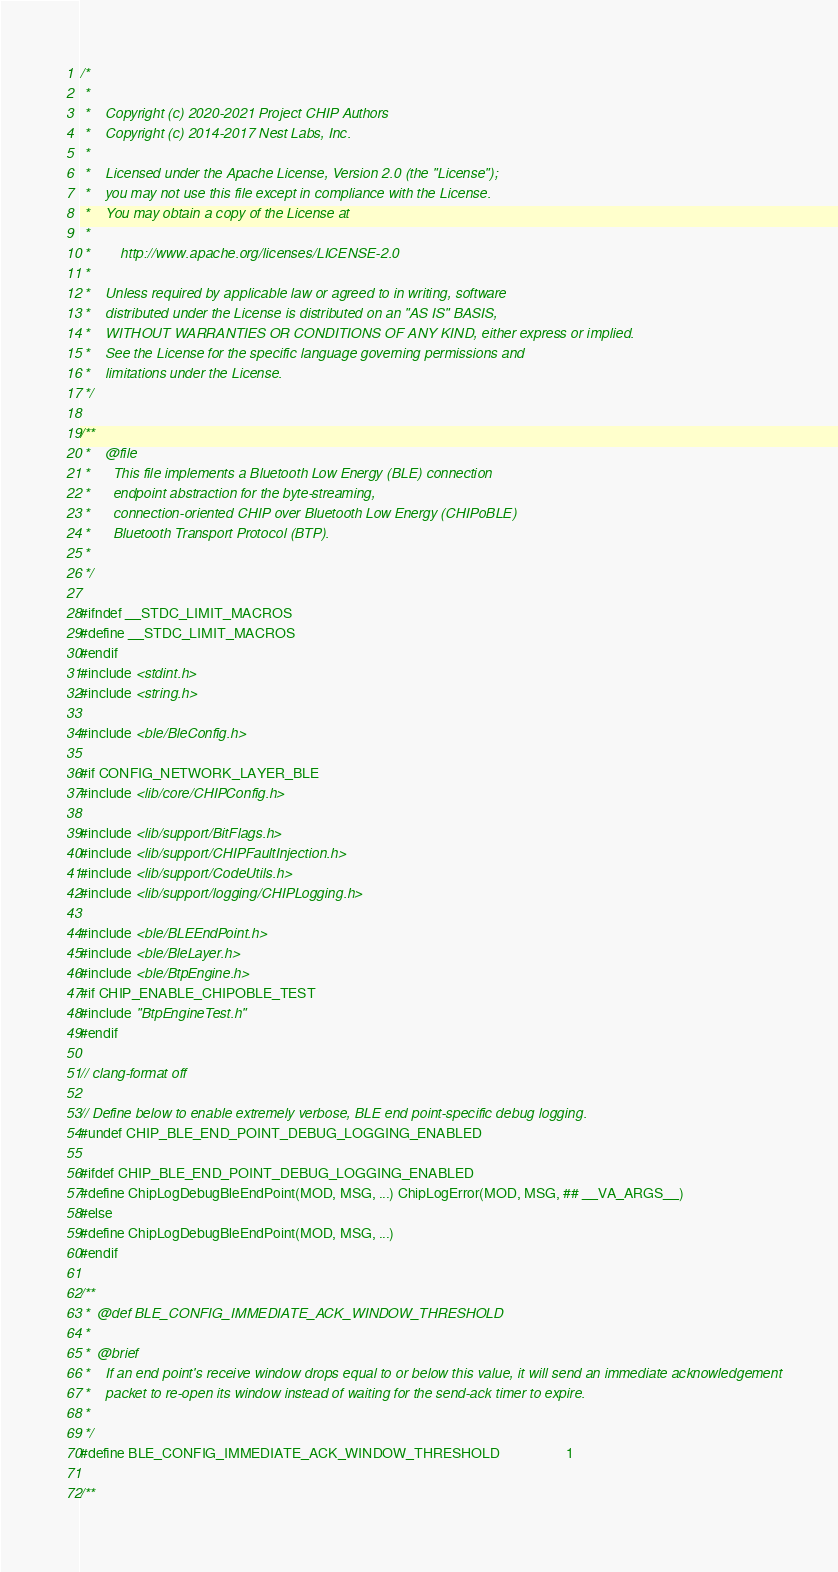<code> <loc_0><loc_0><loc_500><loc_500><_C++_>/*
 *
 *    Copyright (c) 2020-2021 Project CHIP Authors
 *    Copyright (c) 2014-2017 Nest Labs, Inc.
 *
 *    Licensed under the Apache License, Version 2.0 (the "License");
 *    you may not use this file except in compliance with the License.
 *    You may obtain a copy of the License at
 *
 *        http://www.apache.org/licenses/LICENSE-2.0
 *
 *    Unless required by applicable law or agreed to in writing, software
 *    distributed under the License is distributed on an "AS IS" BASIS,
 *    WITHOUT WARRANTIES OR CONDITIONS OF ANY KIND, either express or implied.
 *    See the License for the specific language governing permissions and
 *    limitations under the License.
 */

/**
 *    @file
 *      This file implements a Bluetooth Low Energy (BLE) connection
 *      endpoint abstraction for the byte-streaming,
 *      connection-oriented CHIP over Bluetooth Low Energy (CHIPoBLE)
 *      Bluetooth Transport Protocol (BTP).
 *
 */

#ifndef __STDC_LIMIT_MACROS
#define __STDC_LIMIT_MACROS
#endif
#include <stdint.h>
#include <string.h>

#include <ble/BleConfig.h>

#if CONFIG_NETWORK_LAYER_BLE
#include <lib/core/CHIPConfig.h>

#include <lib/support/BitFlags.h>
#include <lib/support/CHIPFaultInjection.h>
#include <lib/support/CodeUtils.h>
#include <lib/support/logging/CHIPLogging.h>

#include <ble/BLEEndPoint.h>
#include <ble/BleLayer.h>
#include <ble/BtpEngine.h>
#if CHIP_ENABLE_CHIPOBLE_TEST
#include "BtpEngineTest.h"
#endif

// clang-format off

// Define below to enable extremely verbose, BLE end point-specific debug logging.
#undef CHIP_BLE_END_POINT_DEBUG_LOGGING_ENABLED

#ifdef CHIP_BLE_END_POINT_DEBUG_LOGGING_ENABLED
#define ChipLogDebugBleEndPoint(MOD, MSG, ...) ChipLogError(MOD, MSG, ## __VA_ARGS__)
#else
#define ChipLogDebugBleEndPoint(MOD, MSG, ...)
#endif

/**
 *  @def BLE_CONFIG_IMMEDIATE_ACK_WINDOW_THRESHOLD
 *
 *  @brief
 *    If an end point's receive window drops equal to or below this value, it will send an immediate acknowledgement
 *    packet to re-open its window instead of waiting for the send-ack timer to expire.
 *
 */
#define BLE_CONFIG_IMMEDIATE_ACK_WINDOW_THRESHOLD                   1

/**</code> 